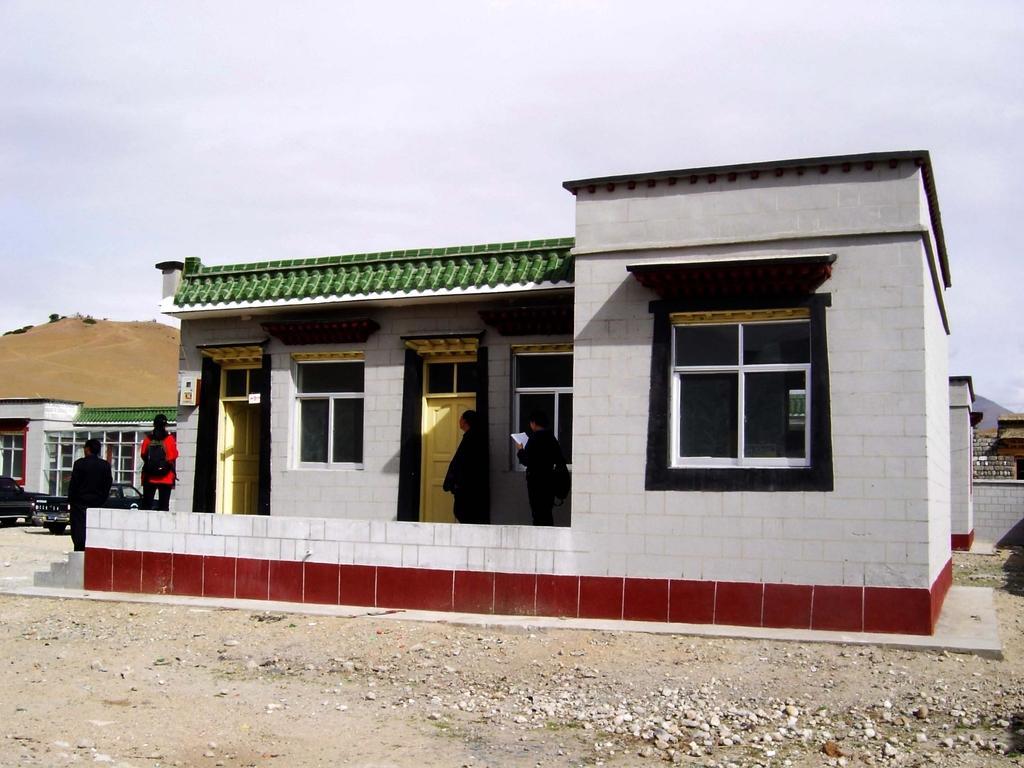Describe this image in one or two sentences. In this image I can see few people standing. The person in front wearing black color dress and I can see white color building. Background the sky is in white color. 